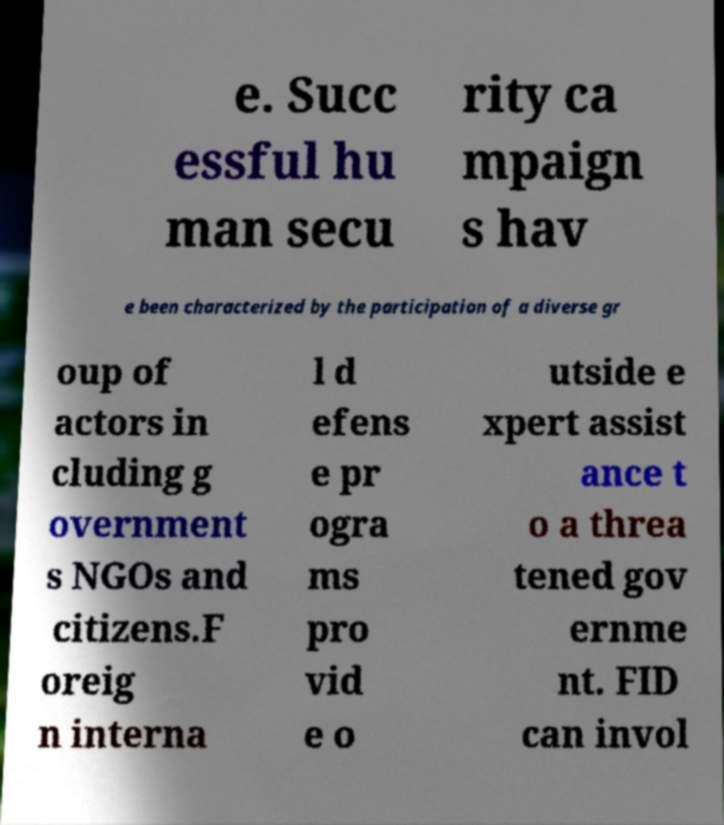Could you assist in decoding the text presented in this image and type it out clearly? e. Succ essful hu man secu rity ca mpaign s hav e been characterized by the participation of a diverse gr oup of actors in cluding g overnment s NGOs and citizens.F oreig n interna l d efens e pr ogra ms pro vid e o utside e xpert assist ance t o a threa tened gov ernme nt. FID can invol 